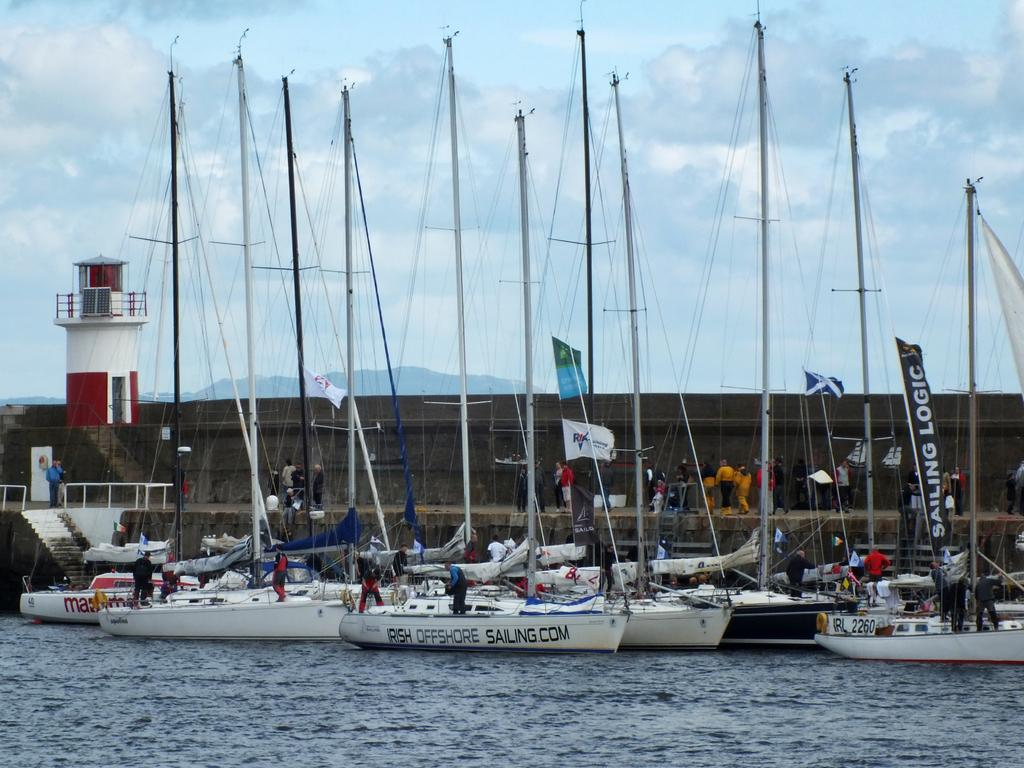<image>
Create a compact narrative representing the image presented. A boat with the website address for Irish Offshore Sailing is docked at a marina. 